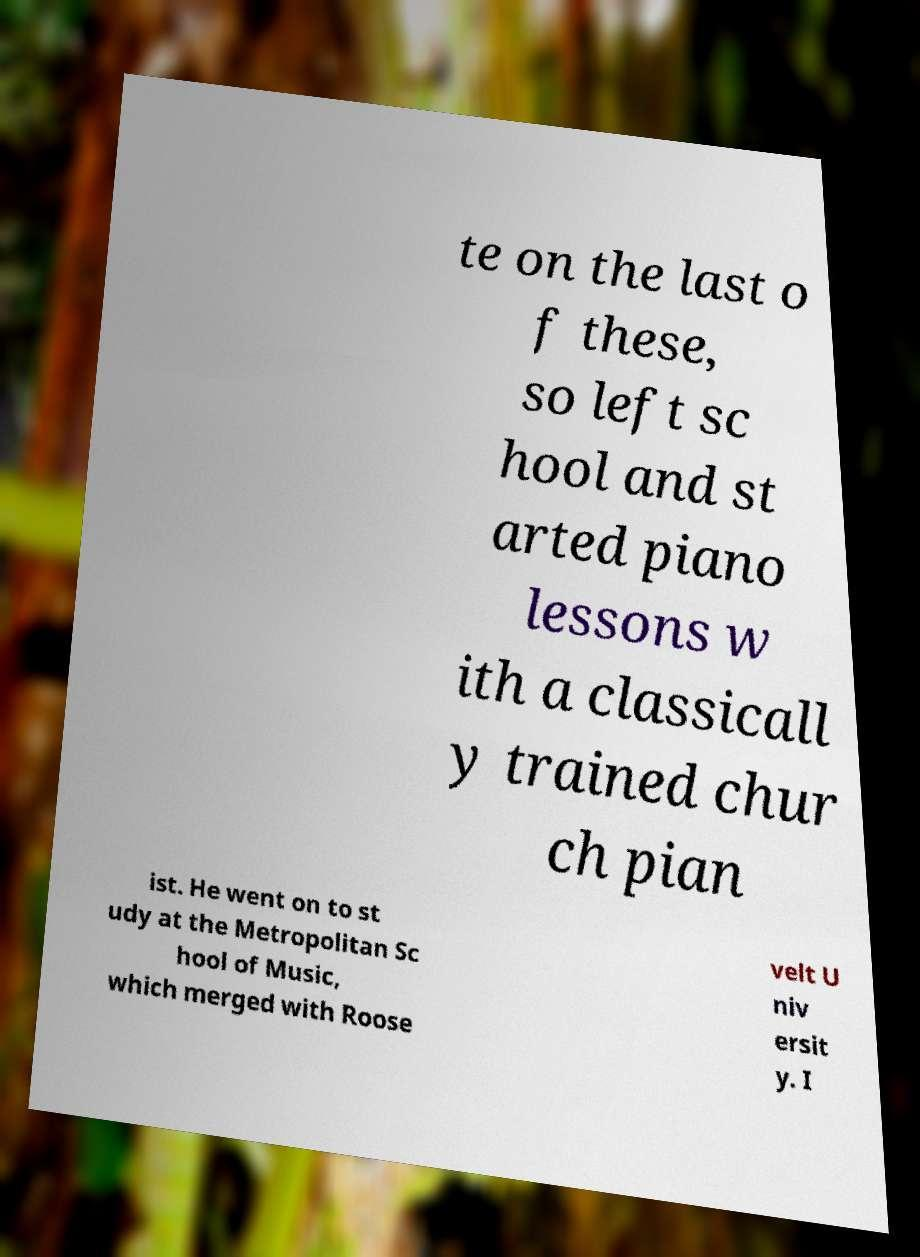What messages or text are displayed in this image? I need them in a readable, typed format. te on the last o f these, so left sc hool and st arted piano lessons w ith a classicall y trained chur ch pian ist. He went on to st udy at the Metropolitan Sc hool of Music, which merged with Roose velt U niv ersit y. I 